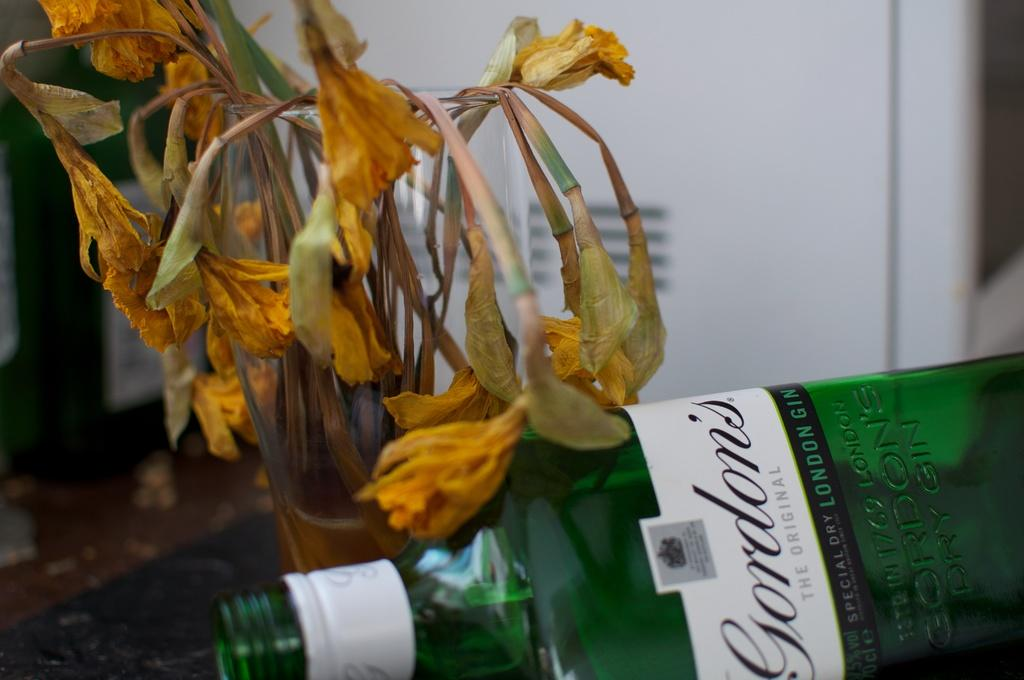What type of bottle is in the image? There is a green color bottle in the image. What else can be seen in the image besides the bottle? There is a plant in the image. What color are the flowers on the plant? The flowers on the plant are yellow in color. Is there any ice visible in the image? No, there is no ice present in the image. Is anyone wearing a coat in the image? There is no person or coat visible in the image. 